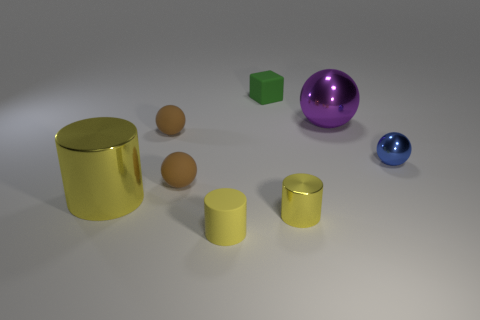Subtract all rubber cylinders. How many cylinders are left? 2 Add 2 small cyan rubber objects. How many objects exist? 10 Subtract all brown balls. How many balls are left? 2 Subtract 1 blocks. How many blocks are left? 0 Subtract all gray cylinders. How many brown spheres are left? 2 Subtract all cubes. How many objects are left? 7 Subtract 0 gray cylinders. How many objects are left? 8 Subtract all green spheres. Subtract all gray blocks. How many spheres are left? 4 Subtract all tiny objects. Subtract all big gray matte spheres. How many objects are left? 2 Add 5 tiny brown matte balls. How many tiny brown matte balls are left? 7 